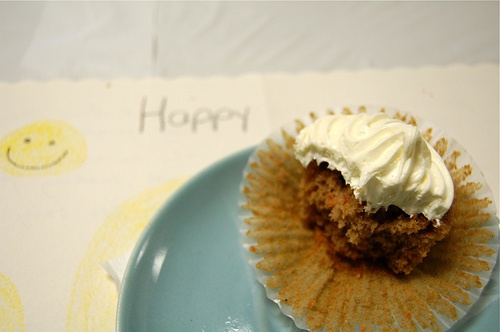Describe the objects in this image and their specific colors. I can see a cake in lightgray, black, beige, lightyellow, and maroon tones in this image. 